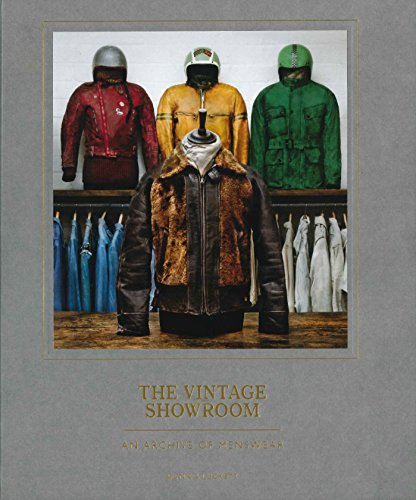What is the title of this book? The title of the book is 'The Vintage Showroom: Vintage Menswear 2', which suggests it focuses on a collection of vintage menswear exploring various styles and historical periods of men's fashion. 